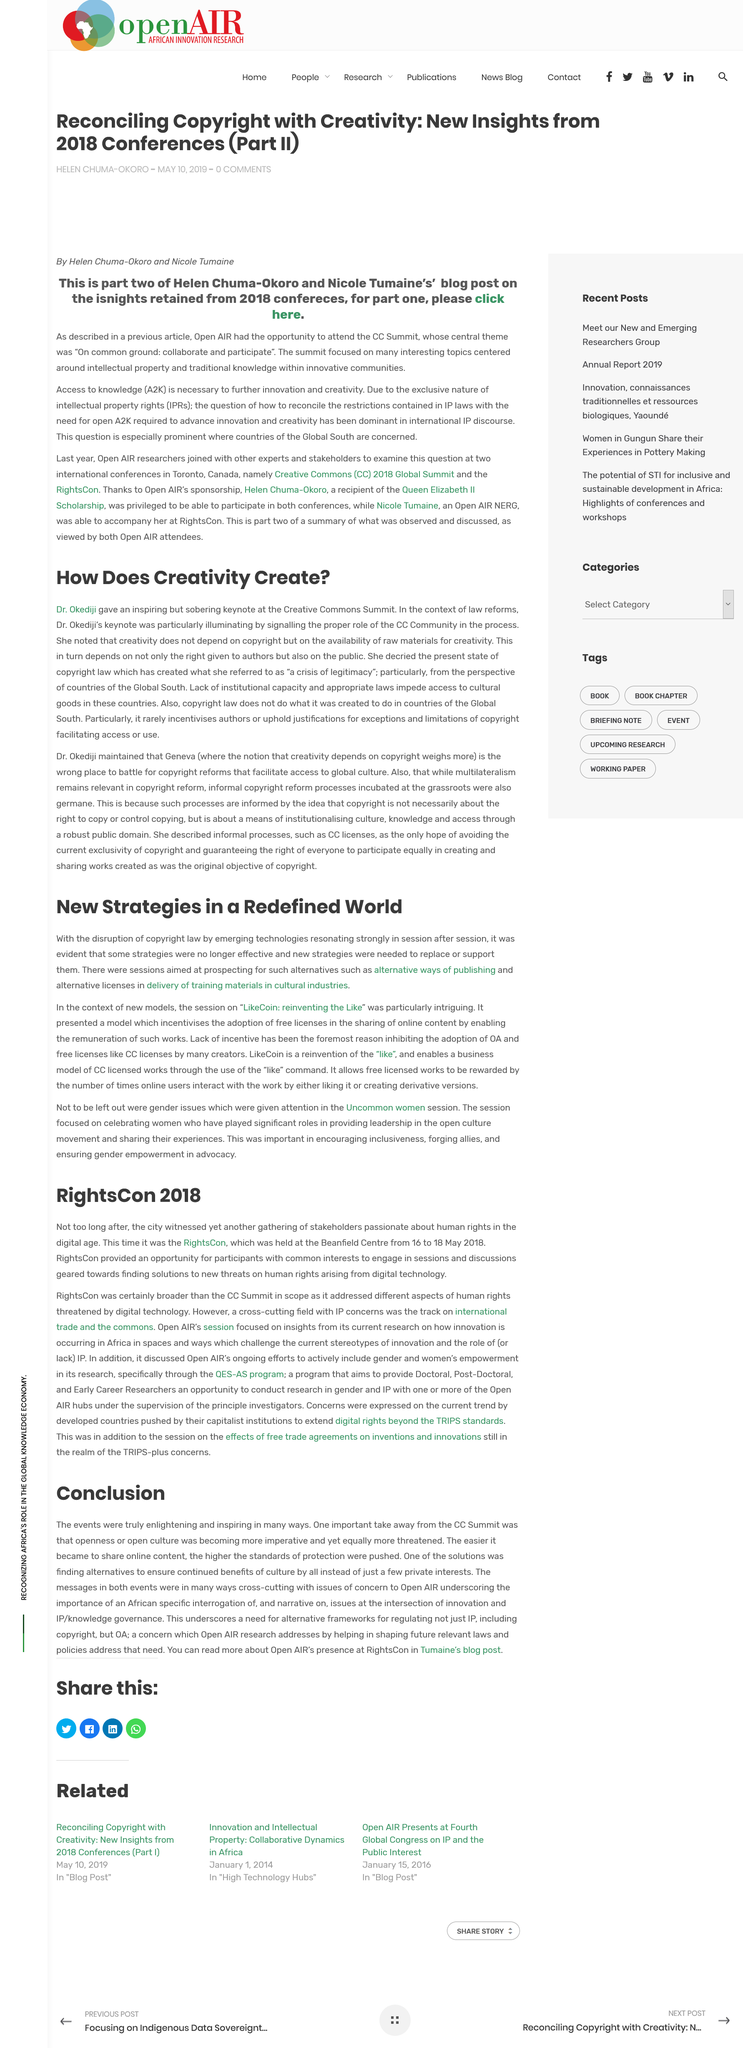List a handful of essential elements in this visual. Dr. Okediji delivered a keynote speech at the Creative Commons Summit, where the location was revealed. Dr. Okediji describes the present state of copyright law as a crisis of legitimacy. Open AIR's presence at RightsCon can be found in Tumaine's blog post, where readers can learn more about the organization's activities at the conference. The acronym AO stands for Open AIR. The speaker declares that Dr. Okediji is a female. 